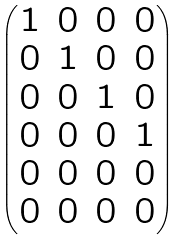<formula> <loc_0><loc_0><loc_500><loc_500>\begin{pmatrix} 1 & 0 & 0 & 0 \\ 0 & 1 & 0 & 0 \\ 0 & 0 & 1 & 0 \\ 0 & 0 & 0 & 1 \\ 0 & 0 & 0 & 0 \\ 0 & 0 & 0 & 0 \\ \end{pmatrix}</formula> 